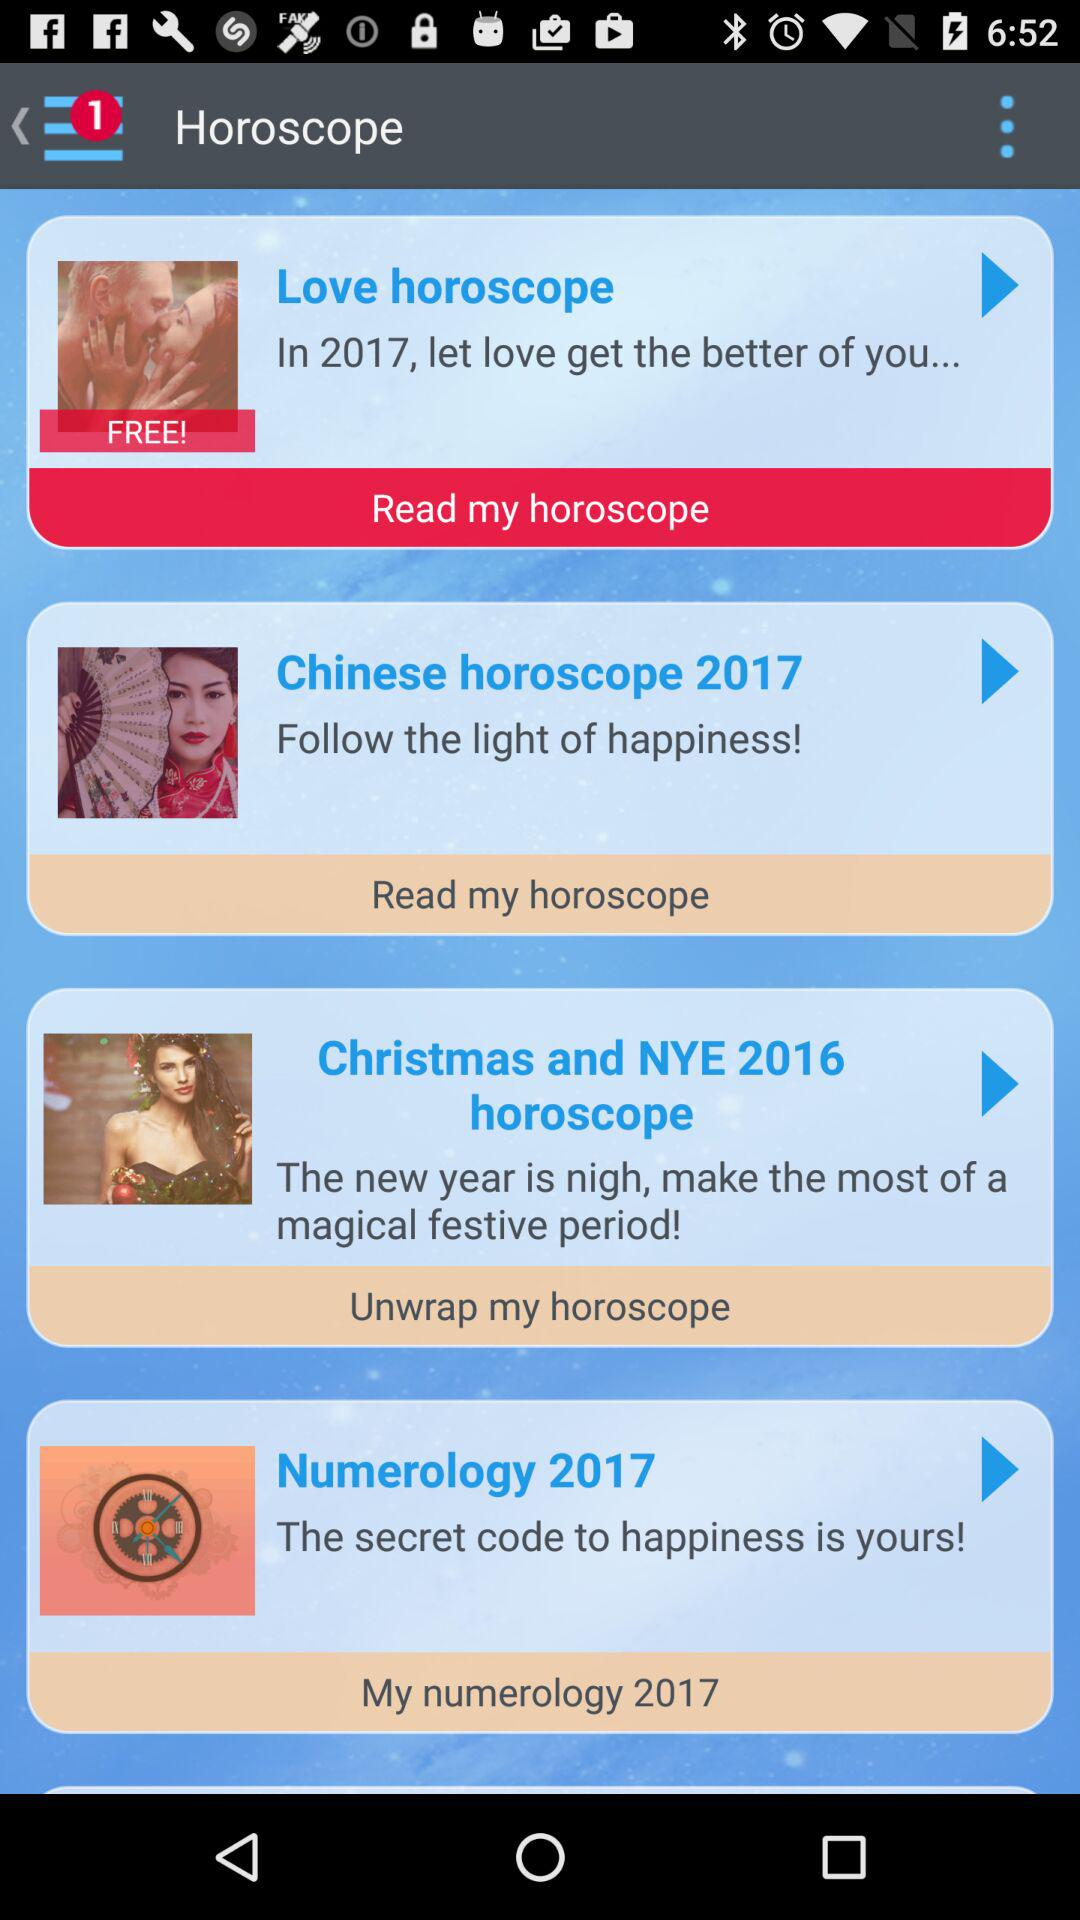How many notifications are there? There is 1 notification. 